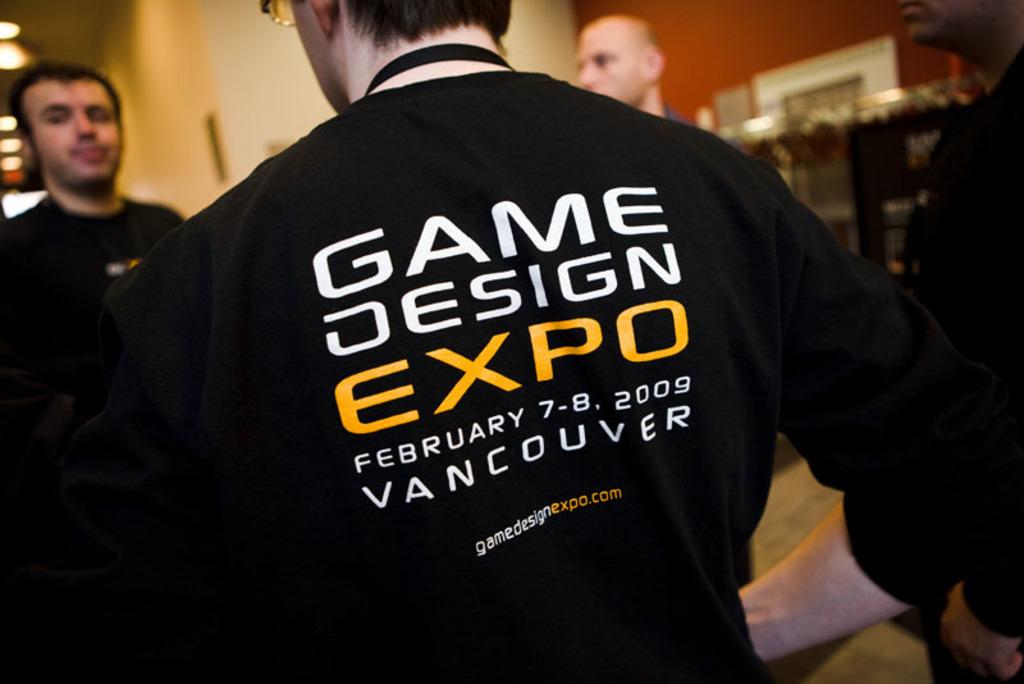Where is the game design expo?
Offer a very short reply. Vancouver. What month is the game design expo?
Your answer should be very brief. February. 